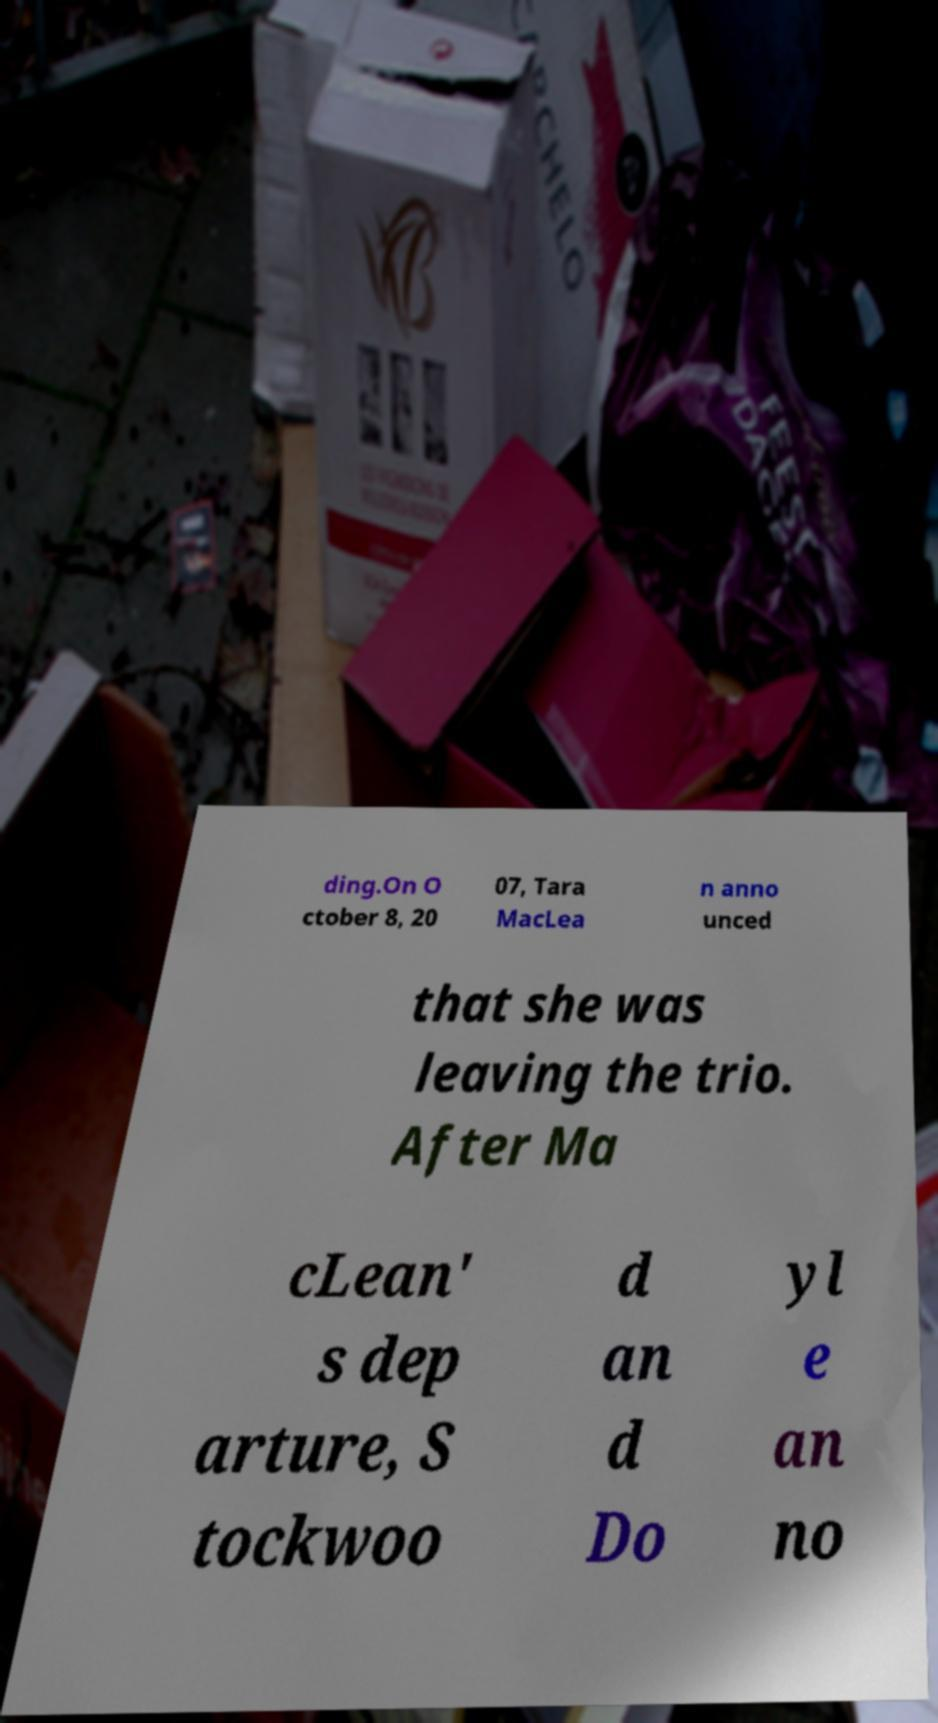There's text embedded in this image that I need extracted. Can you transcribe it verbatim? ding.On O ctober 8, 20 07, Tara MacLea n anno unced that she was leaving the trio. After Ma cLean' s dep arture, S tockwoo d an d Do yl e an no 